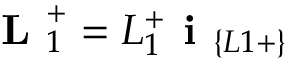Convert formula to latex. <formula><loc_0><loc_0><loc_500><loc_500>L _ { 1 } ^ { + } = L _ { 1 } ^ { + } i _ { \{ L 1 + \} }</formula> 